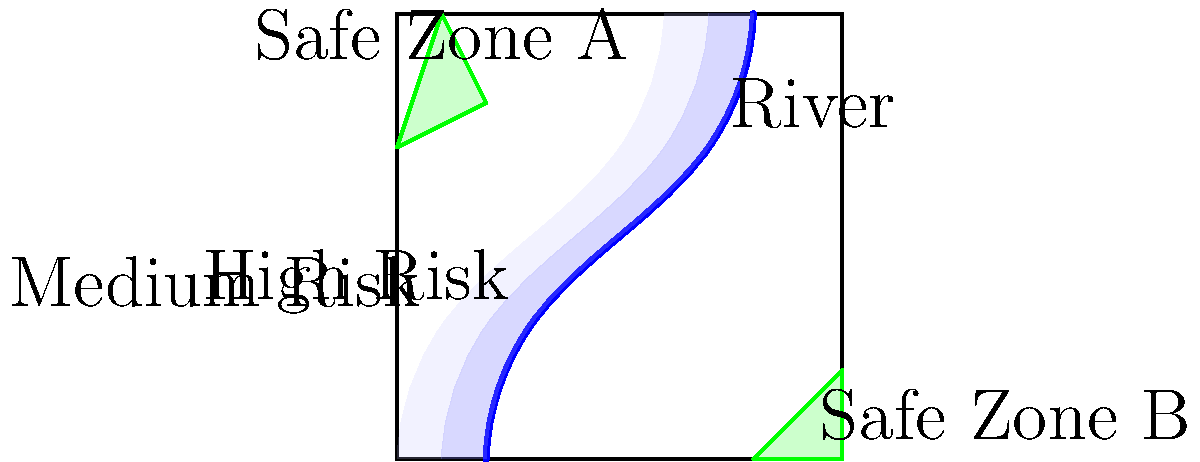Based on the Denver flood map shown, which of the two marked safe zones (A or B) is likely to be more suitable for establishing an emergency shelter during a severe flood event? To determine the more suitable safe zone for an emergency shelter during a severe flood event, we need to consider several factors:

1. Elevation: Higher ground is generally safer during floods.
2. Distance from flood-prone areas: The farther from high-risk zones, the better.
3. Accessibility: The shelter should be reachable by evacuation routes.
4. Size: A larger area can accommodate more people and resources.

Let's analyze each safe zone:

Safe Zone A:
1. Located in the northern part of the map, likely at a higher elevation.
2. Further from the river and high-risk flood zones.
3. Might have limited access due to its position near the map edge.
4. Appears to be a smaller area compared to Safe Zone B.

Safe Zone B:
1. Located in the southeastern part of the map, potentially at a lower elevation.
2. Closer to the river and high-risk flood zones, but still outside them.
3. Likely more accessible due to its position near the map corner.
4. Appears to be a larger area compared to Safe Zone A.

Considering these factors, Safe Zone A is likely to be more suitable for an emergency shelter during a severe flood event. Its higher elevation and greater distance from flood-prone areas make it a safer option, despite its potentially smaller size and limited accessibility.
Answer: Safe Zone A 